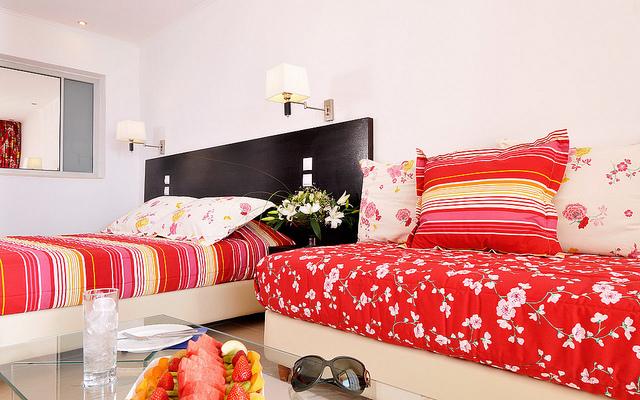What fruit is present?
Concise answer only. Watermelon. What color are these mattresses?
Keep it brief. White. Which room is this?
Quick response, please. Bedroom. 